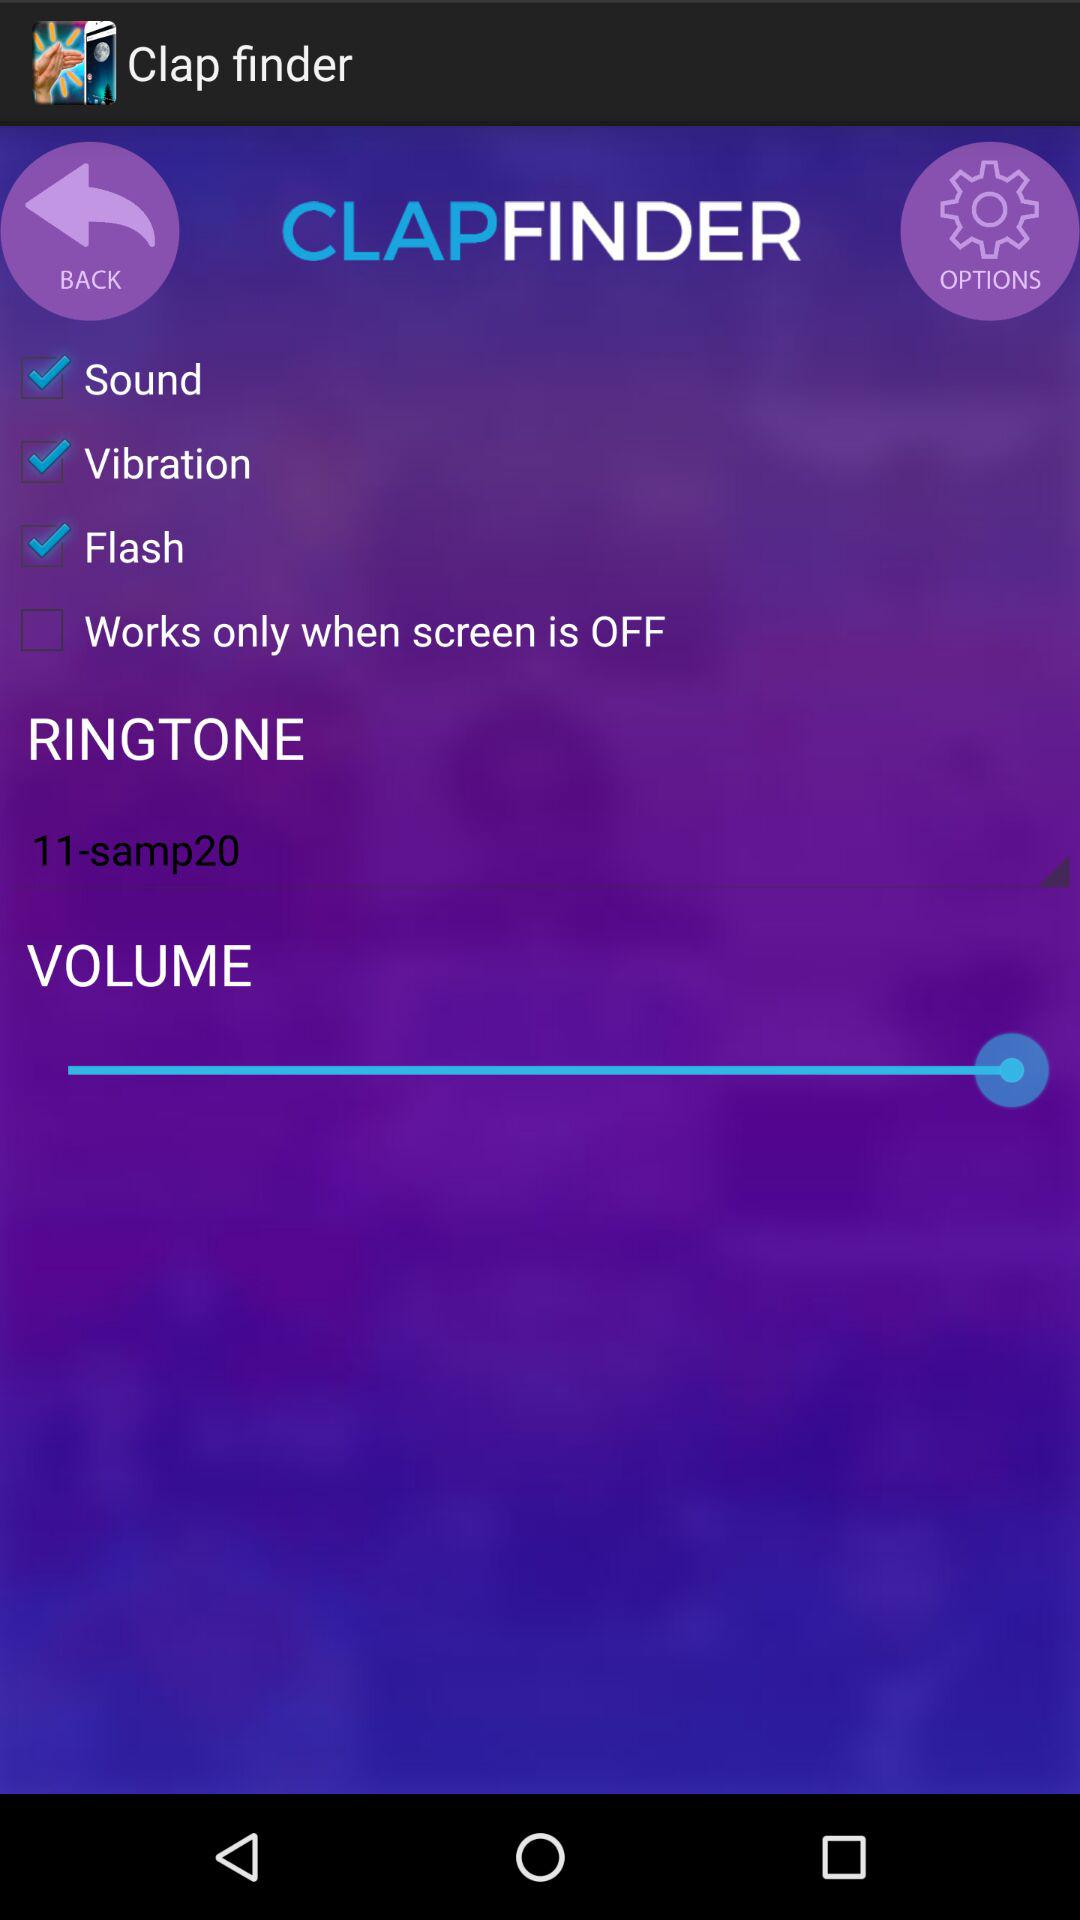What is the name of the application? The name of the application is "Clap finder". 